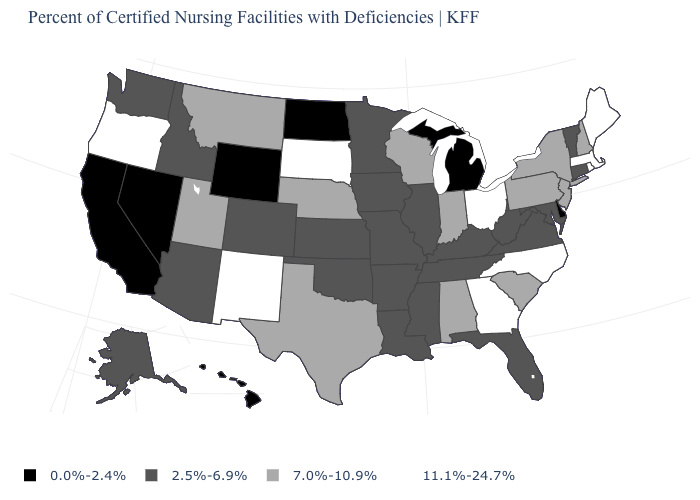What is the value of Montana?
Answer briefly. 7.0%-10.9%. What is the value of Washington?
Write a very short answer. 2.5%-6.9%. What is the value of Idaho?
Short answer required. 2.5%-6.9%. How many symbols are there in the legend?
Give a very brief answer. 4. Is the legend a continuous bar?
Give a very brief answer. No. What is the value of Wyoming?
Quick response, please. 0.0%-2.4%. Name the states that have a value in the range 2.5%-6.9%?
Quick response, please. Alaska, Arizona, Arkansas, Colorado, Connecticut, Florida, Idaho, Illinois, Iowa, Kansas, Kentucky, Louisiana, Maryland, Minnesota, Mississippi, Missouri, Oklahoma, Tennessee, Vermont, Virginia, Washington, West Virginia. What is the highest value in the USA?
Give a very brief answer. 11.1%-24.7%. Does New Mexico have a higher value than Alabama?
Keep it brief. Yes. What is the value of Maryland?
Short answer required. 2.5%-6.9%. Which states have the highest value in the USA?
Be succinct. Georgia, Maine, Massachusetts, New Mexico, North Carolina, Ohio, Oregon, Rhode Island, South Dakota. How many symbols are there in the legend?
Give a very brief answer. 4. What is the value of Rhode Island?
Keep it brief. 11.1%-24.7%. Does Vermont have the lowest value in the Northeast?
Give a very brief answer. Yes. What is the value of Utah?
Short answer required. 7.0%-10.9%. 